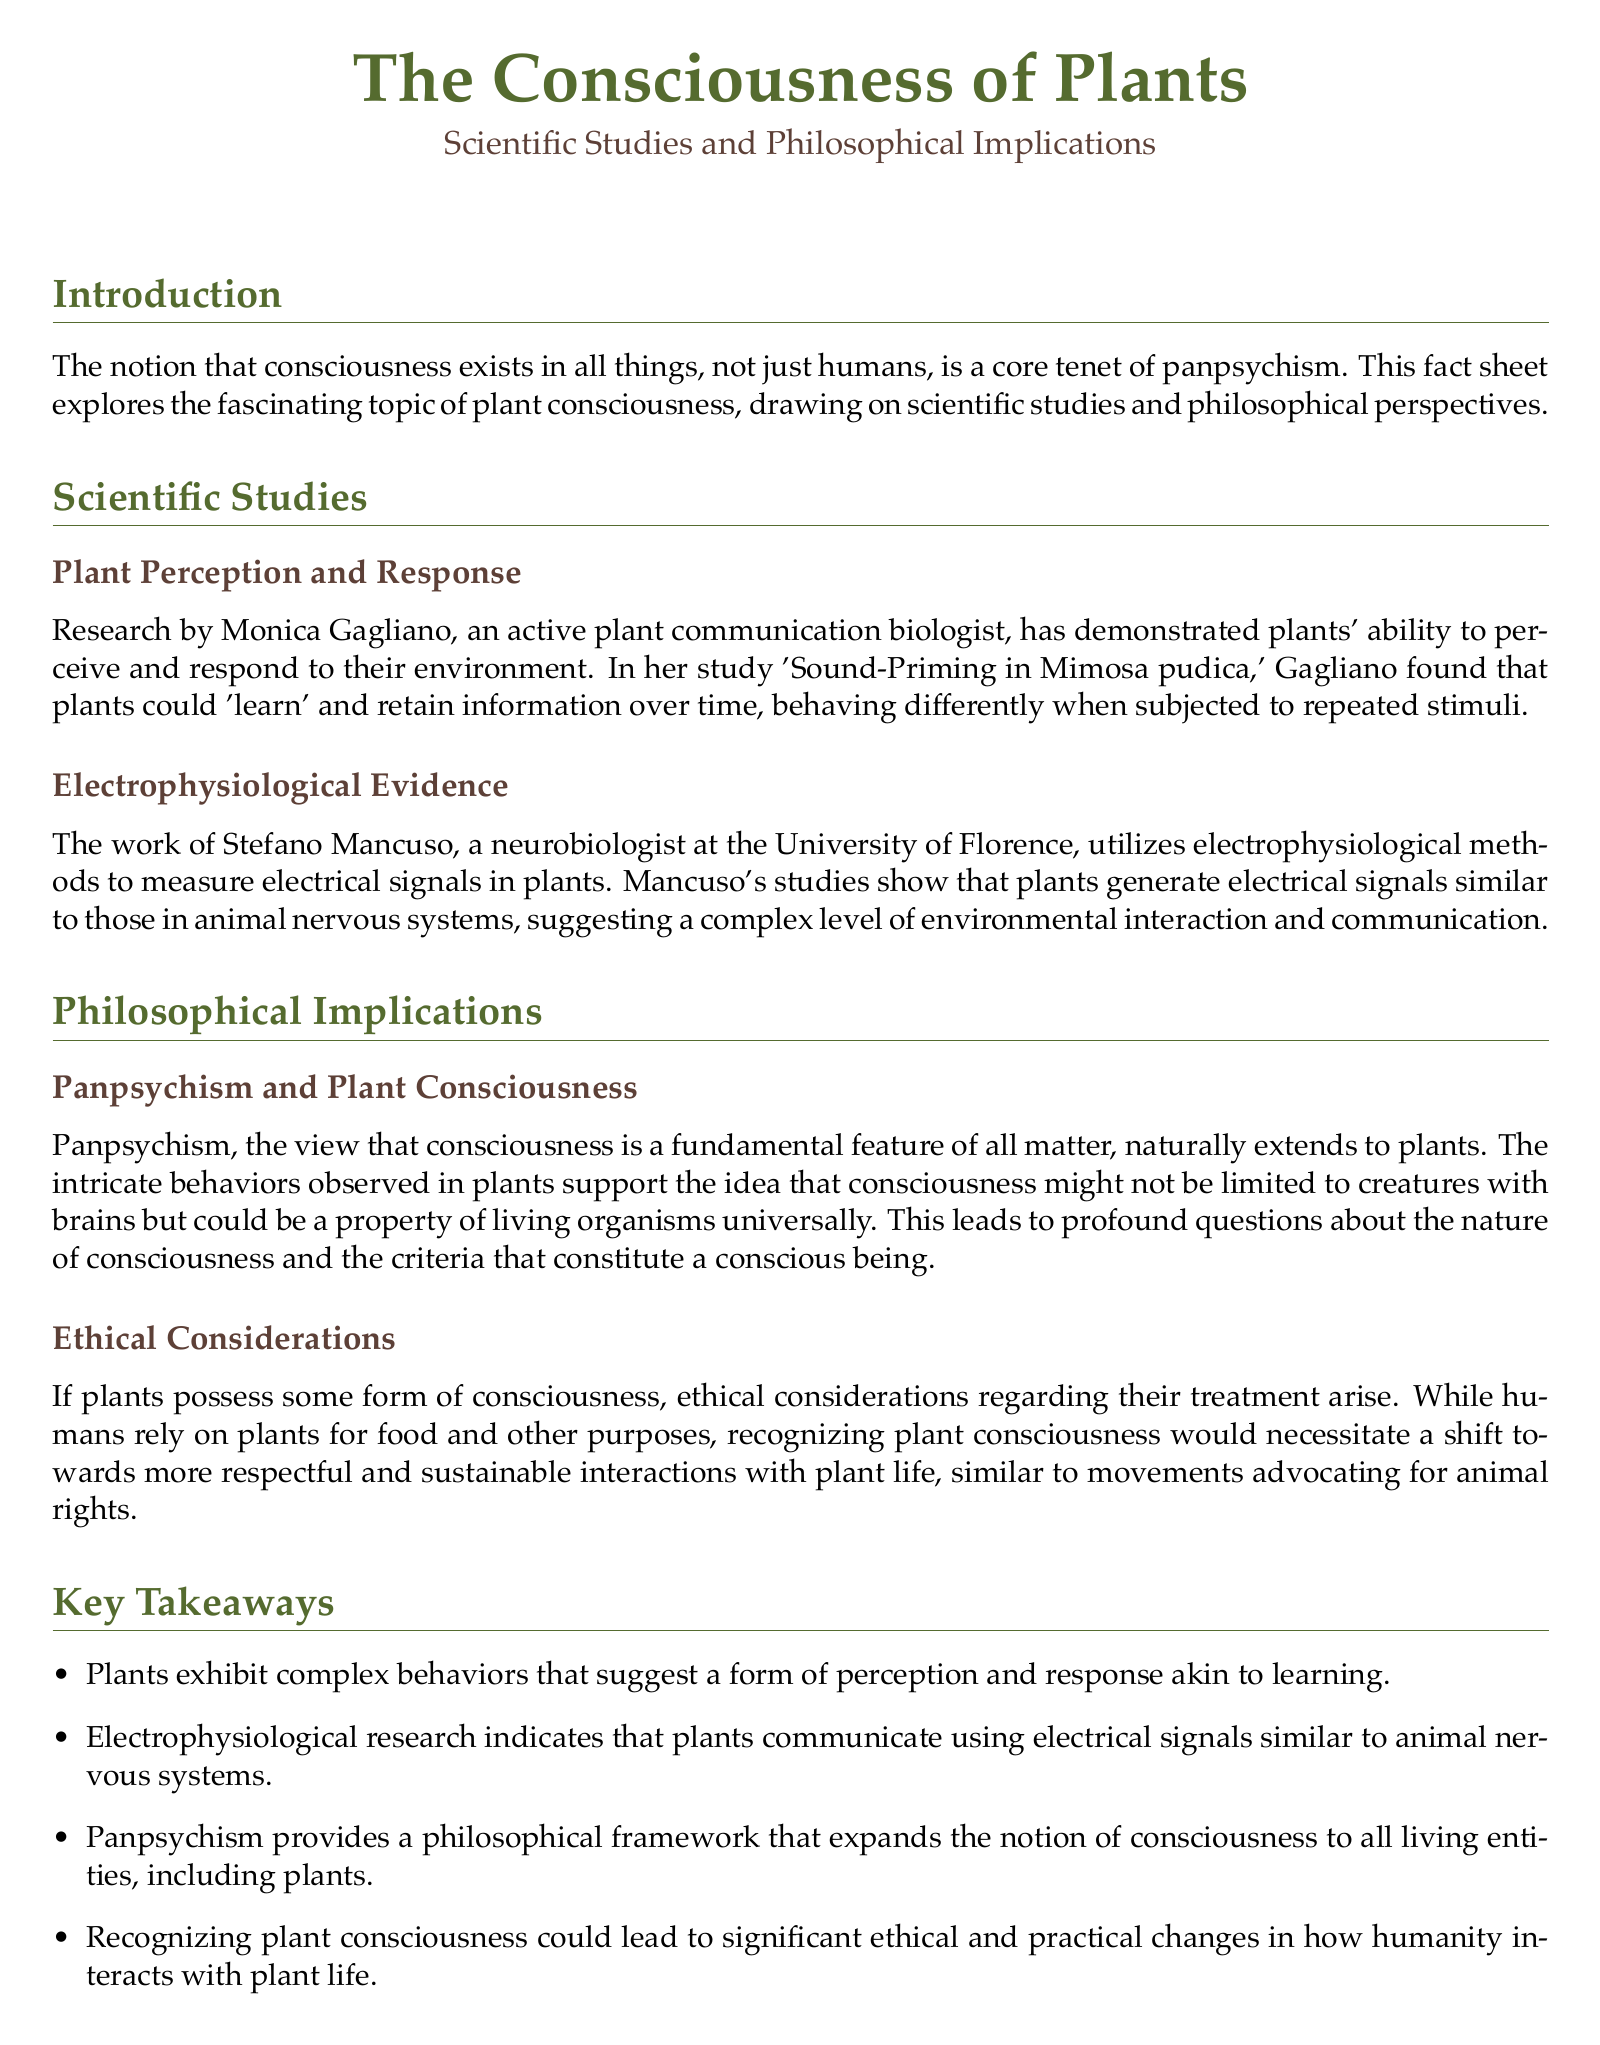What is the title of the study by Monica Gagliano? The title of the study is 'Sound-Priming in Mimosa pudica'.
Answer: 'Sound-Priming in Mimosa pudica' Who conducted research on electrophysiological methods in plants? The research on electrophysiological methods in plants was conducted by Stefano Mancuso.
Answer: Stefano Mancuso What is the primary philosophical framework discussed in relation to plant consciousness? The primary philosophical framework discussed is panpsychism.
Answer: panpsychism What year was 'Brilliant Green: The Surprising History and Science of Plant Intelligence' published? The book was published in 2015.
Answer: 2015 Which behavior suggests that plants have a form of perception? The behavior that suggests this is their ability to 'learn' and retain information over time.
Answer: 'learn' and retain information What ethical considerations are mentioned regarding plants? The ethical considerations involve recognizing plant consciousness and the need for more respectful and sustainable interactions with them.
Answer: More respectful and sustainable interactions What key takeaway mentions electrical signals in plants? The takeaway indicates that electrophysiological research shows plants communicate using electrical signals similar to animal nervous systems.
Answer: Electrical signals similar to animal nervous systems What does the document propose might change if plant consciousness is recognized? The document proposes that it could lead to significant ethical and practical changes in how humanity interacts with plant life.
Answer: Significant ethical and practical changes 